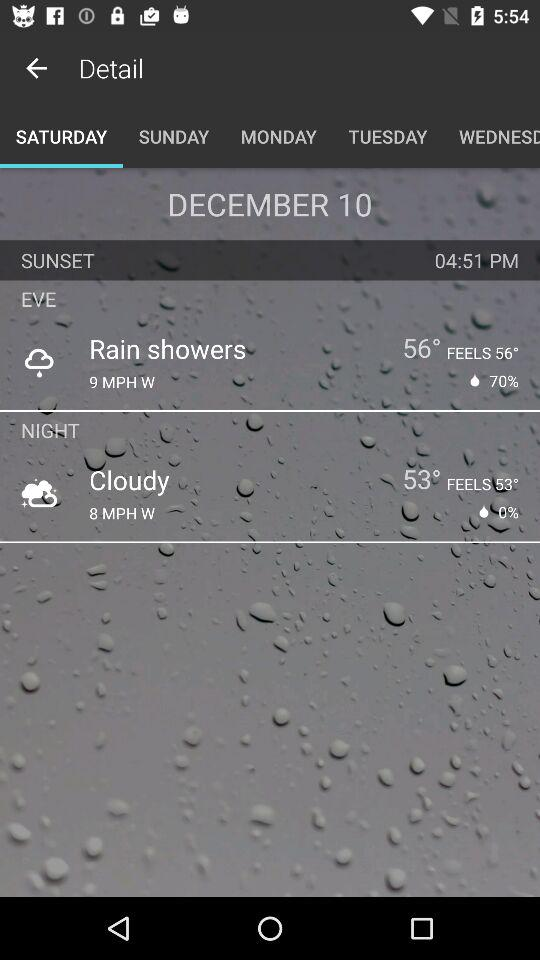What is the sunset time? The sunset time is 4:51 p.m. 